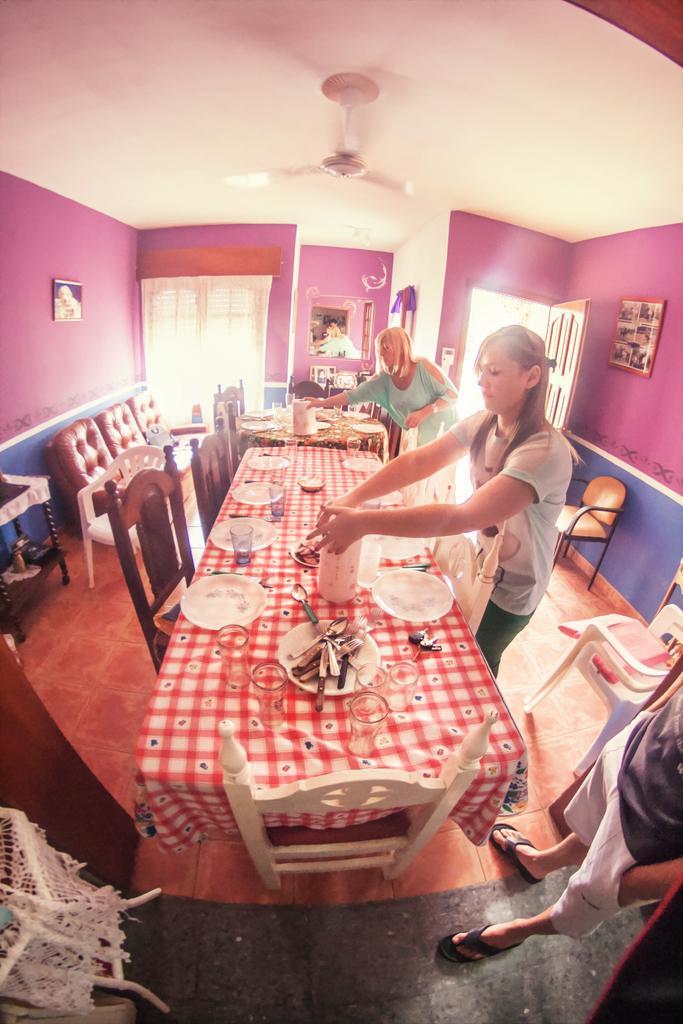How would you summarize this image in a sentence or two? In this image there are three people two women and one man ,they are standing and working. There is a table on which there are spoons,bowls,bottle and a cloth. There are chairs around the table and there is sofa to the left corner and their is a door at the right corner. At the top there is a fan. 